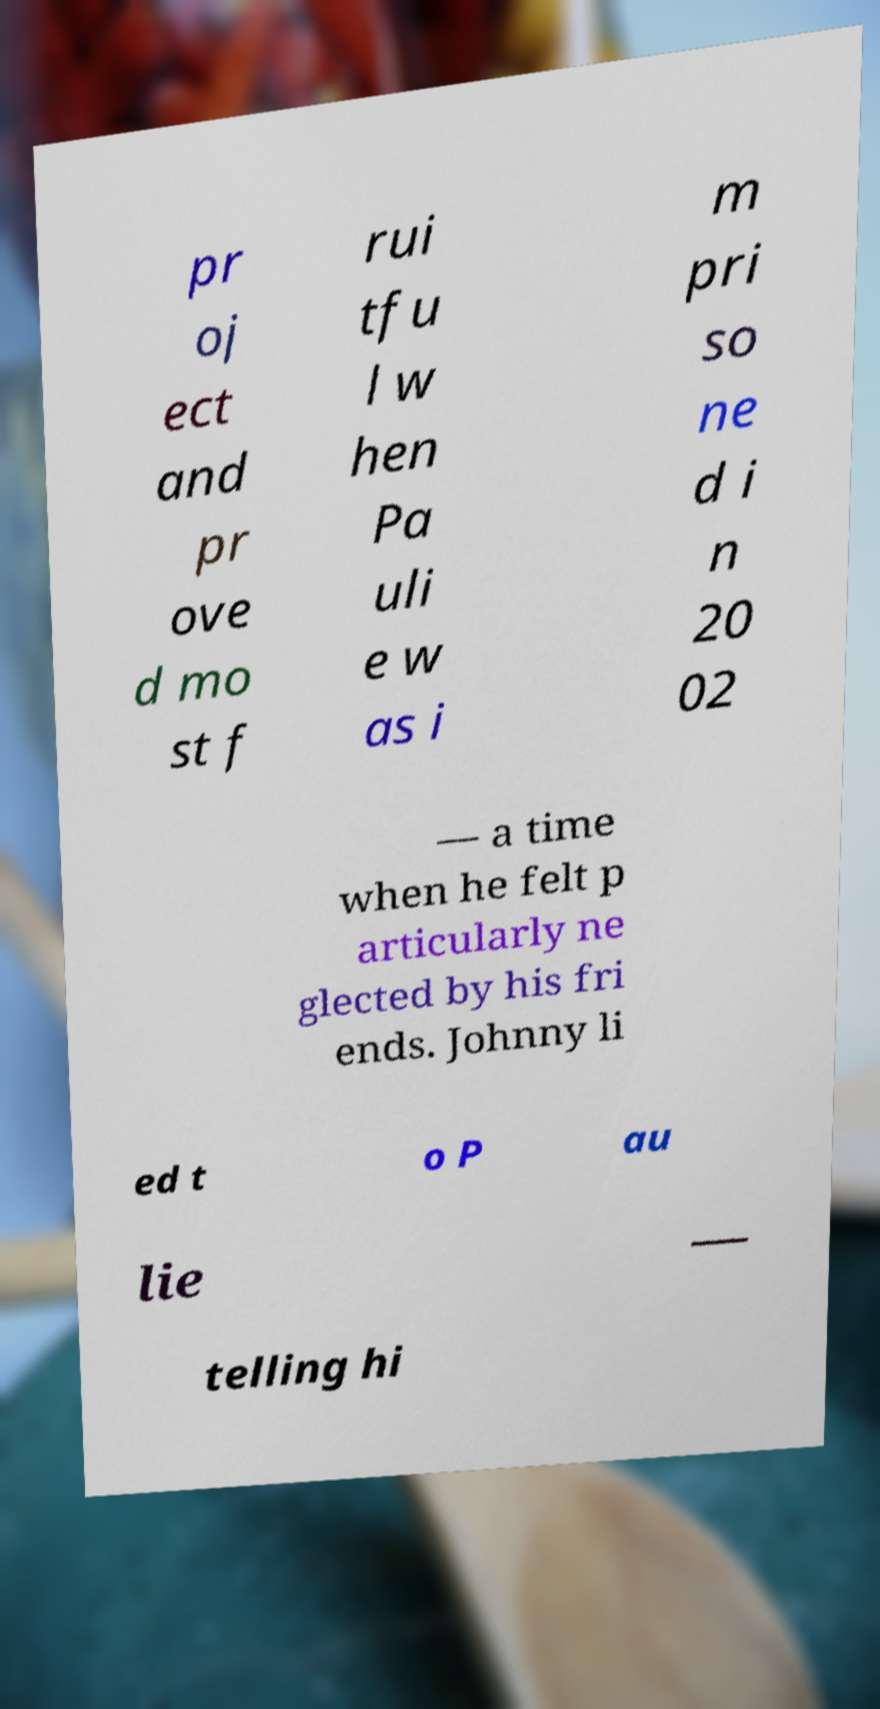I need the written content from this picture converted into text. Can you do that? pr oj ect and pr ove d mo st f rui tfu l w hen Pa uli e w as i m pri so ne d i n 20 02 — a time when he felt p articularly ne glected by his fri ends. Johnny li ed t o P au lie — telling hi 